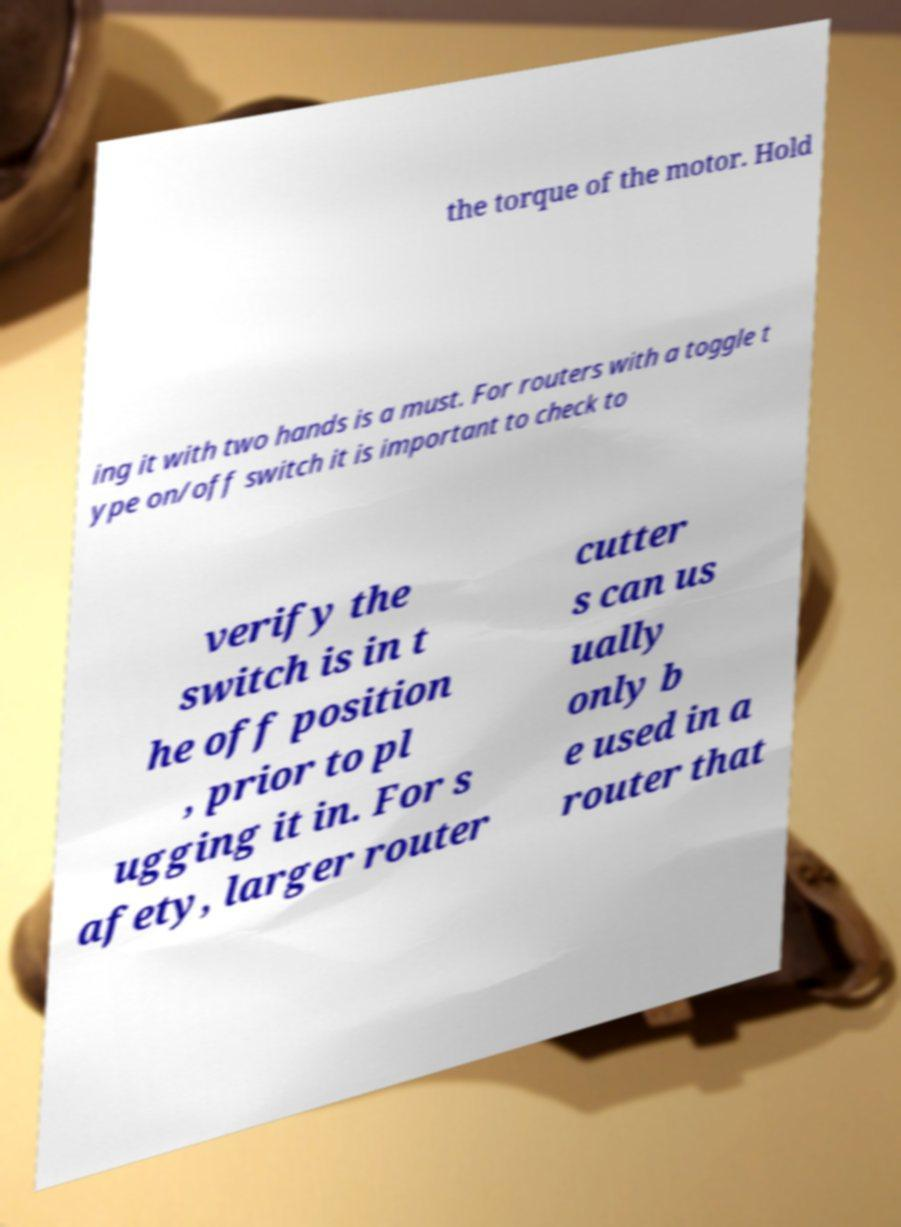Can you accurately transcribe the text from the provided image for me? the torque of the motor. Hold ing it with two hands is a must. For routers with a toggle t ype on/off switch it is important to check to verify the switch is in t he off position , prior to pl ugging it in. For s afety, larger router cutter s can us ually only b e used in a router that 